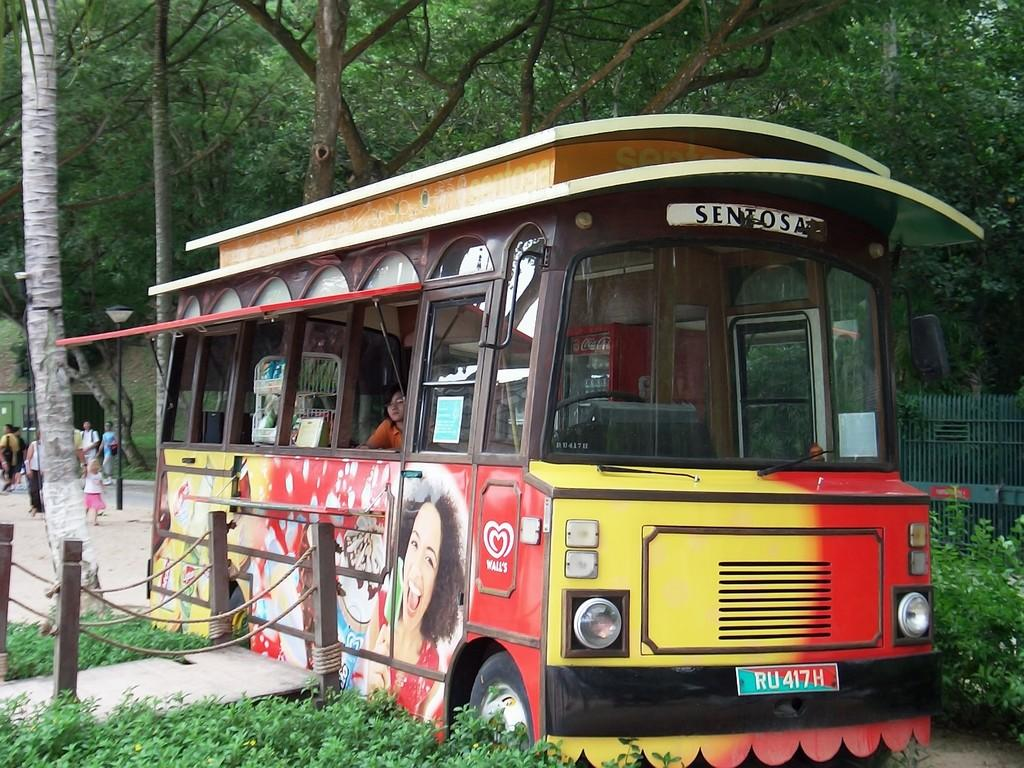What type of vehicle is in the image? There is a food vehicle in the image. Who is inside the food vehicle? A person is present in the food vehicle. What can be seen on the left side of the image? There are people on the left side of the image. What is visible at the top of the image? Trees are visible at the top of the image. How many ladybugs are crawling on the food vehicle in the image? There are no ladybugs present in the image. What type of expansion is the food vehicle undergoing in the image? The image does not show any expansion of the food vehicle. 